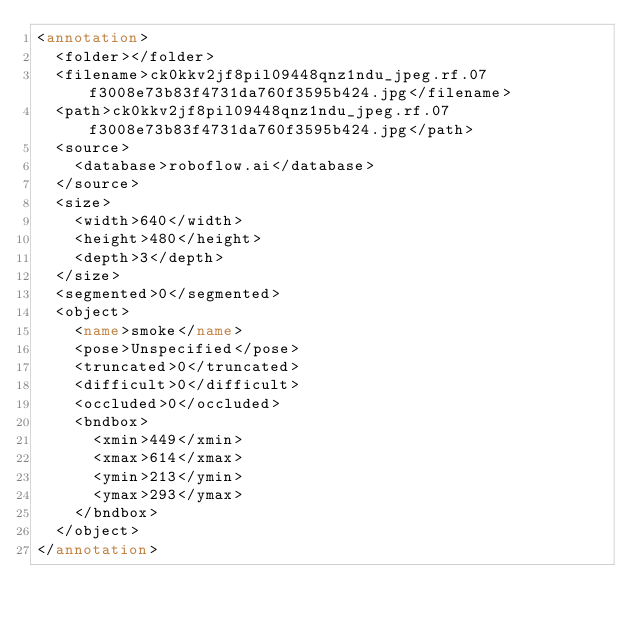<code> <loc_0><loc_0><loc_500><loc_500><_XML_><annotation>
	<folder></folder>
	<filename>ck0kkv2jf8pil09448qnz1ndu_jpeg.rf.07f3008e73b83f4731da760f3595b424.jpg</filename>
	<path>ck0kkv2jf8pil09448qnz1ndu_jpeg.rf.07f3008e73b83f4731da760f3595b424.jpg</path>
	<source>
		<database>roboflow.ai</database>
	</source>
	<size>
		<width>640</width>
		<height>480</height>
		<depth>3</depth>
	</size>
	<segmented>0</segmented>
	<object>
		<name>smoke</name>
		<pose>Unspecified</pose>
		<truncated>0</truncated>
		<difficult>0</difficult>
		<occluded>0</occluded>
		<bndbox>
			<xmin>449</xmin>
			<xmax>614</xmax>
			<ymin>213</ymin>
			<ymax>293</ymax>
		</bndbox>
	</object>
</annotation>
</code> 